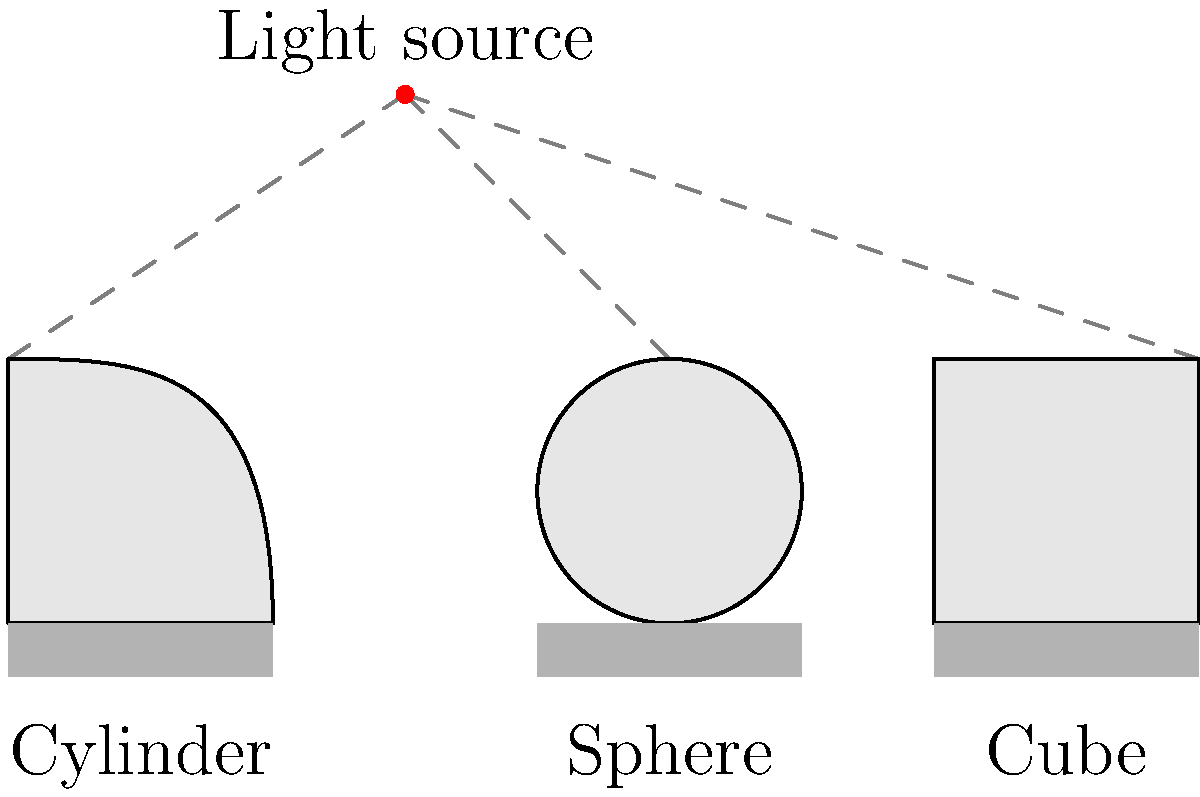In the given still life composition, how does the position of the light source affect the shadow patterns of the cylinder, sphere, and cube? Analyze the differences in shadow formation and explain how a concept artist might use this understanding to create more realistic and dynamic sketches. 1. Light source position: The light source is positioned above and to the left of the objects, creating a consistent lighting direction across the composition.

2. Cylinder shadow:
   - The cylinder casts an elongated shadow due to its vertical orientation.
   - The shadow is darkest near the base and gradually fades as it extends away from the object.
   - The curved surface of the cylinder creates a gradual transition from light to shadow on its body.

3. Sphere shadow:
   - The sphere casts a circular shadow directly beneath it.
   - The shadow is most intense at the center and softens towards the edges.
   - The curved surface of the sphere creates a smooth gradient from highlight to shadow.

4. Cube shadow:
   - The cube casts a angular shadow with sharp edges.
   - The shadow is uniform in intensity due to the flat surfaces of the cube.
   - The cube's faces create distinct planes of light and shadow with clear transitions.

5. Artistic application:
   - Understanding these shadow patterns allows a concept artist to:
     a) Create more realistic lighting in their sketches by accurately representing how different shapes interact with light.
     b) Use shadow direction and intensity to convey the position and strength of light sources.
     c) Enhance the three-dimensionality of objects by correctly rendering the interplay of light and shadow on various surfaces.
     d) Manipulate mood and atmosphere in compositions by adjusting the contrast between light and shadow areas.

6. Dynamic sketching:
   - Artists can experiment with different light source positions to create varying shadow effects and compositions.
   - By studying how shadows change with object shape and light position, artists can quickly sketch realistic lighting scenarios without direct reference.
   - This knowledge allows for more creative and expressive use of light and shadow in conceptual designs and illustrations.
Answer: Shadow patterns vary based on object shape: cylinders cast elongated shadows with gradual transitions, spheres create circular shadows with smooth gradients, and cubes produce angular shadows with sharp edges. Understanding these differences enables concept artists to create more realistic and dynamic sketches by accurately representing light-object interactions and enhancing three-dimensionality. 